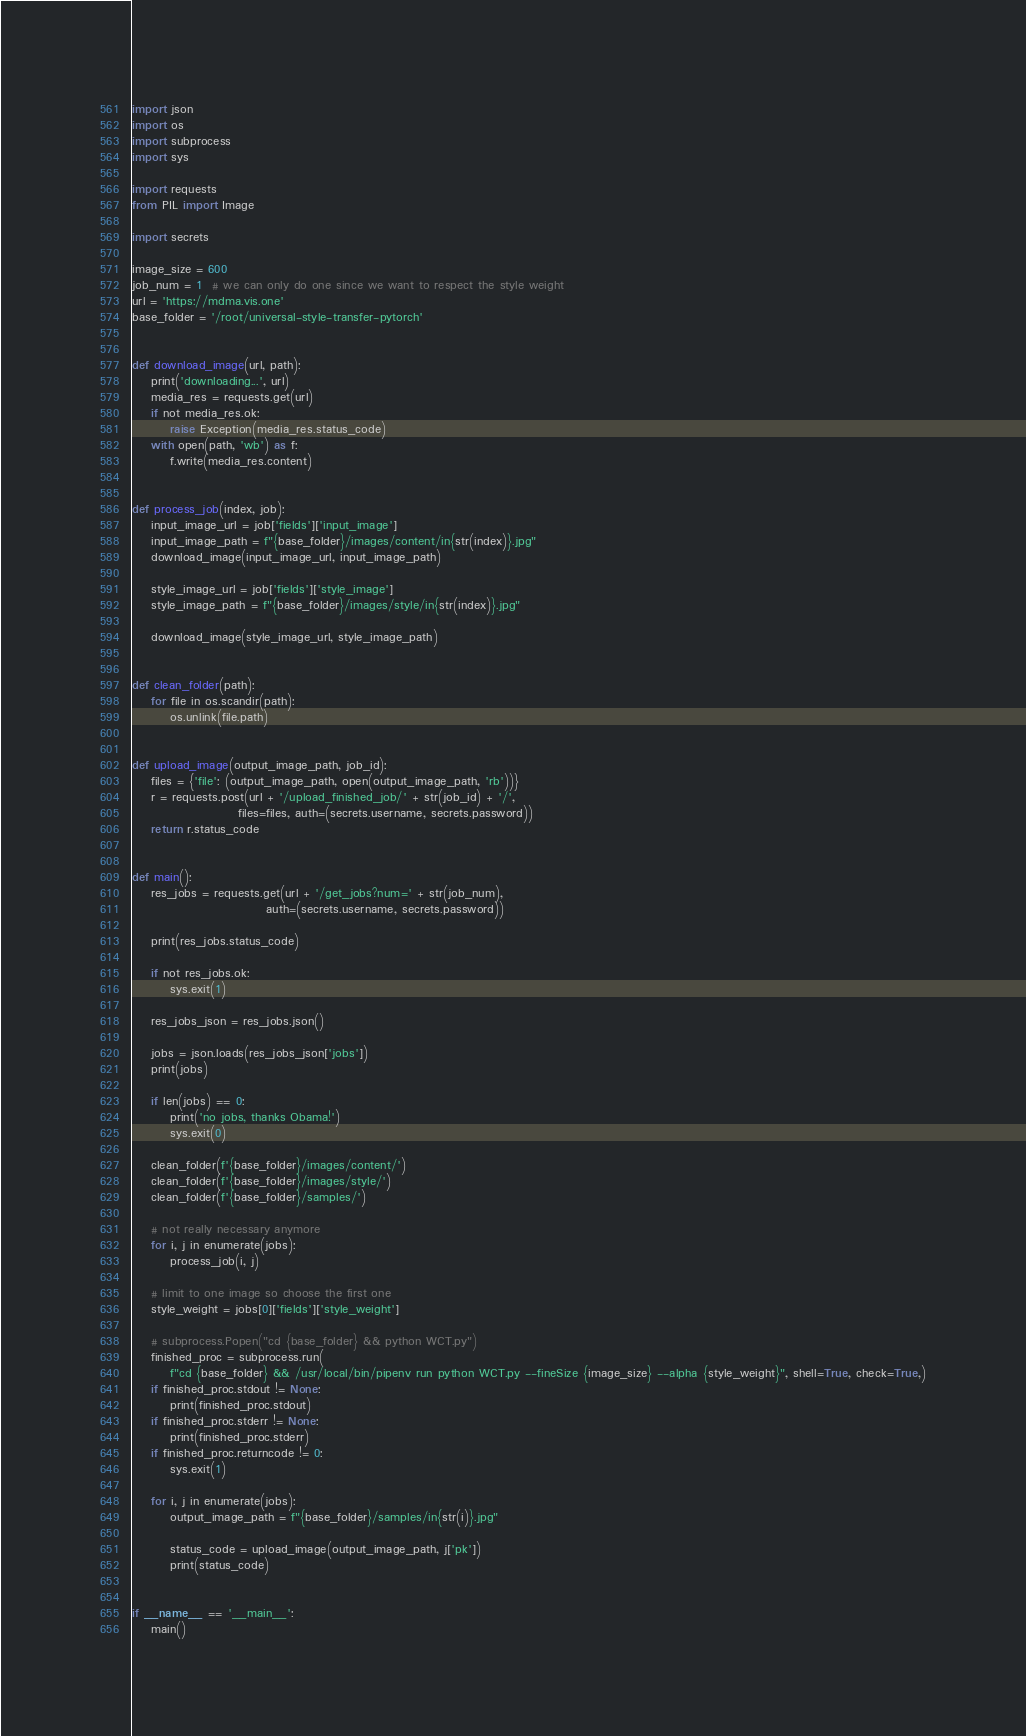Convert code to text. <code><loc_0><loc_0><loc_500><loc_500><_Python_>import json
import os
import subprocess
import sys

import requests
from PIL import Image

import secrets

image_size = 600
job_num = 1  # we can only do one since we want to respect the style weight
url = 'https://mdma.vis.one'
base_folder = '/root/universal-style-transfer-pytorch'


def download_image(url, path):
    print('downloading...', url)
    media_res = requests.get(url)
    if not media_res.ok:
        raise Exception(media_res.status_code)
    with open(path, 'wb') as f:
        f.write(media_res.content)


def process_job(index, job):
    input_image_url = job['fields']['input_image']
    input_image_path = f"{base_folder}/images/content/in{str(index)}.jpg"
    download_image(input_image_url, input_image_path)

    style_image_url = job['fields']['style_image']
    style_image_path = f"{base_folder}/images/style/in{str(index)}.jpg"

    download_image(style_image_url, style_image_path)


def clean_folder(path):
    for file in os.scandir(path):
        os.unlink(file.path)


def upload_image(output_image_path, job_id):
    files = {'file': (output_image_path, open(output_image_path, 'rb'))}
    r = requests.post(url + '/upload_finished_job/' + str(job_id) + '/',
                      files=files, auth=(secrets.username, secrets.password))
    return r.status_code


def main():
    res_jobs = requests.get(url + '/get_jobs?num=' + str(job_num),
                            auth=(secrets.username, secrets.password))

    print(res_jobs.status_code)

    if not res_jobs.ok:
        sys.exit(1)

    res_jobs_json = res_jobs.json()

    jobs = json.loads(res_jobs_json['jobs'])
    print(jobs)

    if len(jobs) == 0:
        print('no jobs, thanks Obama!')
        sys.exit(0)

    clean_folder(f'{base_folder}/images/content/')
    clean_folder(f'{base_folder}/images/style/')
    clean_folder(f'{base_folder}/samples/')

    # not really necessary anymore
    for i, j in enumerate(jobs):
        process_job(i, j)

    # limit to one image so choose the first one
    style_weight = jobs[0]['fields']['style_weight']

    # subprocess.Popen("cd {base_folder} && python WCT.py")
    finished_proc = subprocess.run(
        f"cd {base_folder} && /usr/local/bin/pipenv run python WCT.py --fineSize {image_size} --alpha {style_weight}", shell=True, check=True,)
    if finished_proc.stdout != None:
        print(finished_proc.stdout)
    if finished_proc.stderr != None:
        print(finished_proc.stderr)
    if finished_proc.returncode != 0:
        sys.exit(1)

    for i, j in enumerate(jobs):
        output_image_path = f"{base_folder}/samples/in{str(i)}.jpg"

        status_code = upload_image(output_image_path, j['pk'])
        print(status_code)


if __name__ == '__main__':
    main()
</code> 